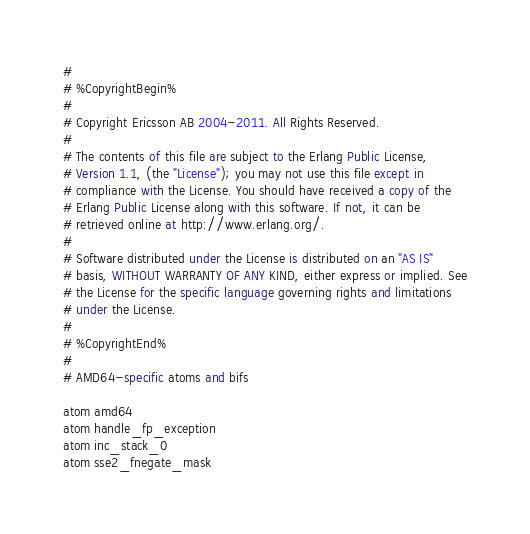<code> <loc_0><loc_0><loc_500><loc_500><_SQL_>#
# %CopyrightBegin%
#
# Copyright Ericsson AB 2004-2011. All Rights Reserved.
#
# The contents of this file are subject to the Erlang Public License,
# Version 1.1, (the "License"); you may not use this file except in
# compliance with the License. You should have received a copy of the
# Erlang Public License along with this software. If not, it can be
# retrieved online at http://www.erlang.org/.
#
# Software distributed under the License is distributed on an "AS IS"
# basis, WITHOUT WARRANTY OF ANY KIND, either express or implied. See
# the License for the specific language governing rights and limitations
# under the License.
#
# %CopyrightEnd%
#
# AMD64-specific atoms and bifs

atom amd64
atom handle_fp_exception
atom inc_stack_0
atom sse2_fnegate_mask
</code> 